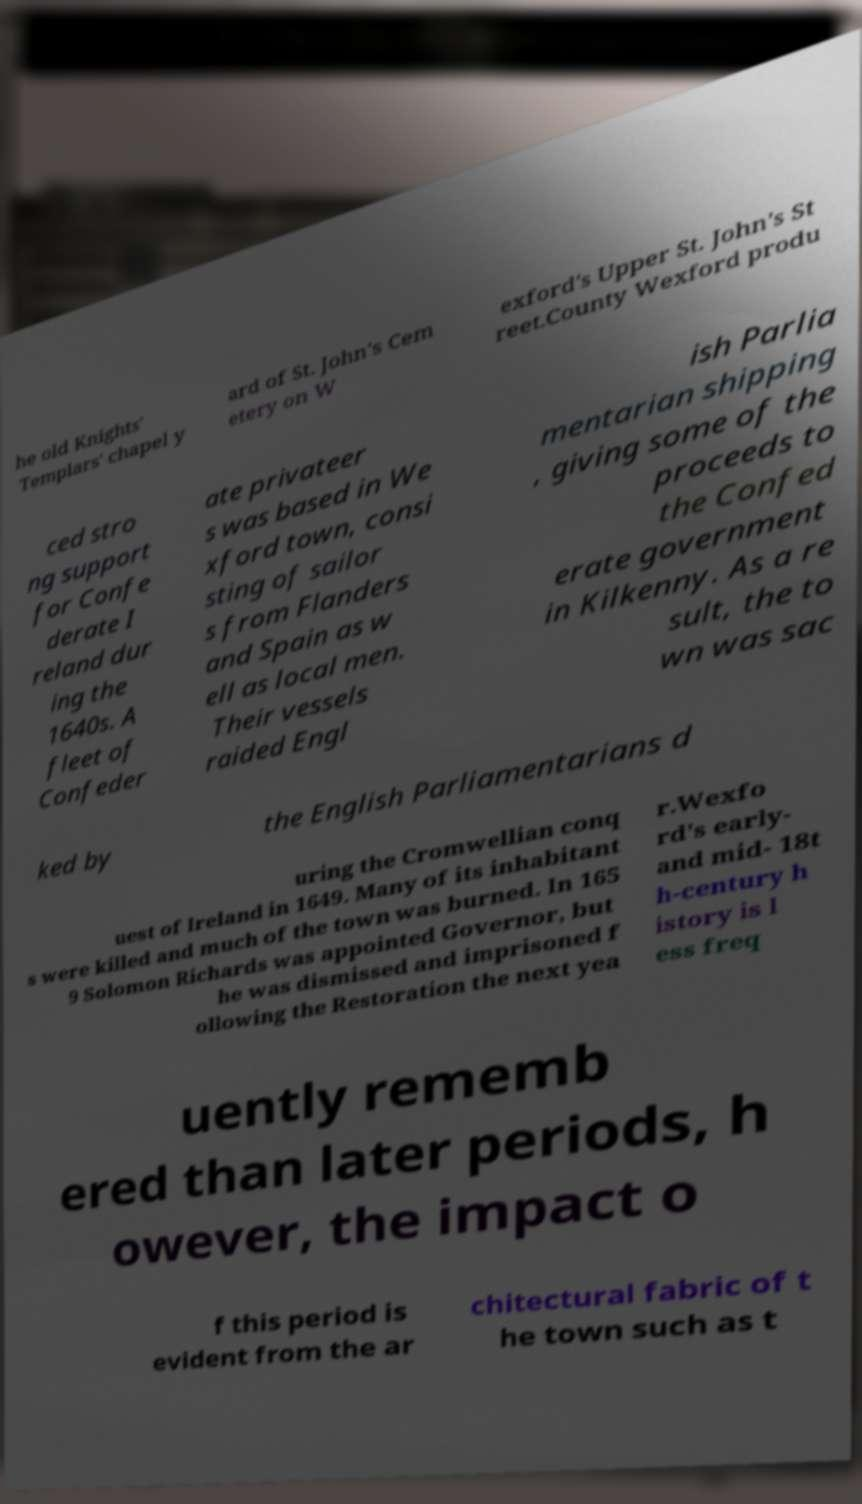Please identify and transcribe the text found in this image. he old Knights' Templars' chapel y ard of St. John's Cem etery on W exford's Upper St. John's St reet.County Wexford produ ced stro ng support for Confe derate I reland dur ing the 1640s. A fleet of Confeder ate privateer s was based in We xford town, consi sting of sailor s from Flanders and Spain as w ell as local men. Their vessels raided Engl ish Parlia mentarian shipping , giving some of the proceeds to the Confed erate government in Kilkenny. As a re sult, the to wn was sac ked by the English Parliamentarians d uring the Cromwellian conq uest of Ireland in 1649. Many of its inhabitant s were killed and much of the town was burned. In 165 9 Solomon Richards was appointed Governor, but he was dismissed and imprisoned f ollowing the Restoration the next yea r.Wexfo rd's early- and mid- 18t h-century h istory is l ess freq uently rememb ered than later periods, h owever, the impact o f this period is evident from the ar chitectural fabric of t he town such as t 